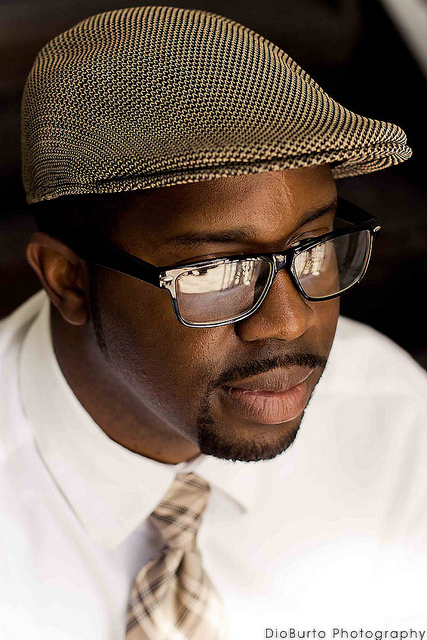Identify the text contained in this image. DioBurto Photography 